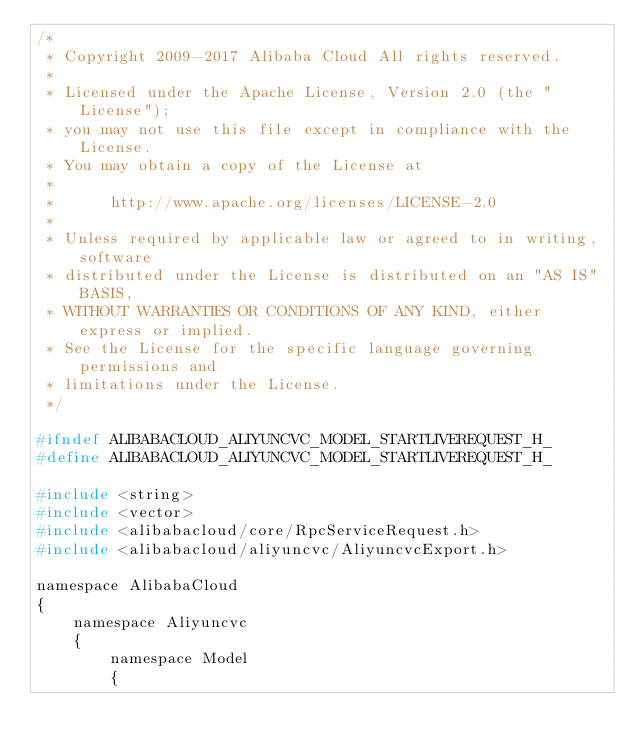Convert code to text. <code><loc_0><loc_0><loc_500><loc_500><_C_>/*
 * Copyright 2009-2017 Alibaba Cloud All rights reserved.
 * 
 * Licensed under the Apache License, Version 2.0 (the "License");
 * you may not use this file except in compliance with the License.
 * You may obtain a copy of the License at
 * 
 *      http://www.apache.org/licenses/LICENSE-2.0
 * 
 * Unless required by applicable law or agreed to in writing, software
 * distributed under the License is distributed on an "AS IS" BASIS,
 * WITHOUT WARRANTIES OR CONDITIONS OF ANY KIND, either express or implied.
 * See the License for the specific language governing permissions and
 * limitations under the License.
 */

#ifndef ALIBABACLOUD_ALIYUNCVC_MODEL_STARTLIVEREQUEST_H_
#define ALIBABACLOUD_ALIYUNCVC_MODEL_STARTLIVEREQUEST_H_

#include <string>
#include <vector>
#include <alibabacloud/core/RpcServiceRequest.h>
#include <alibabacloud/aliyuncvc/AliyuncvcExport.h>

namespace AlibabaCloud
{
	namespace Aliyuncvc
	{
		namespace Model
		{</code> 